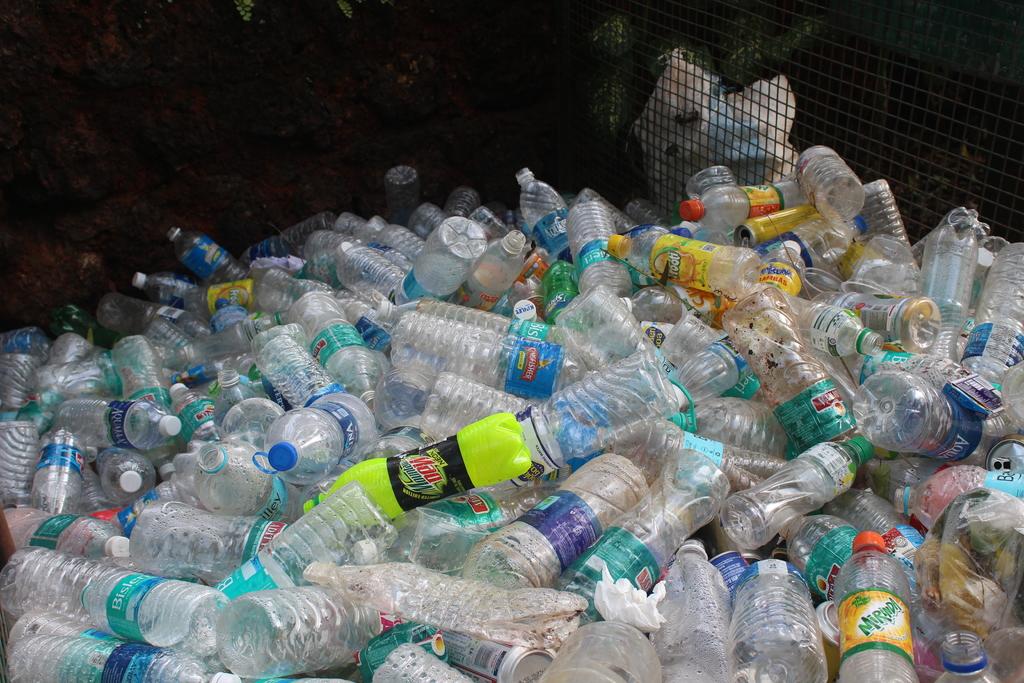What's the brand name on the green bottle?
Provide a succinct answer. Mountain dew. What is a brand of water in the pile?
Your response must be concise. Aquafina. 